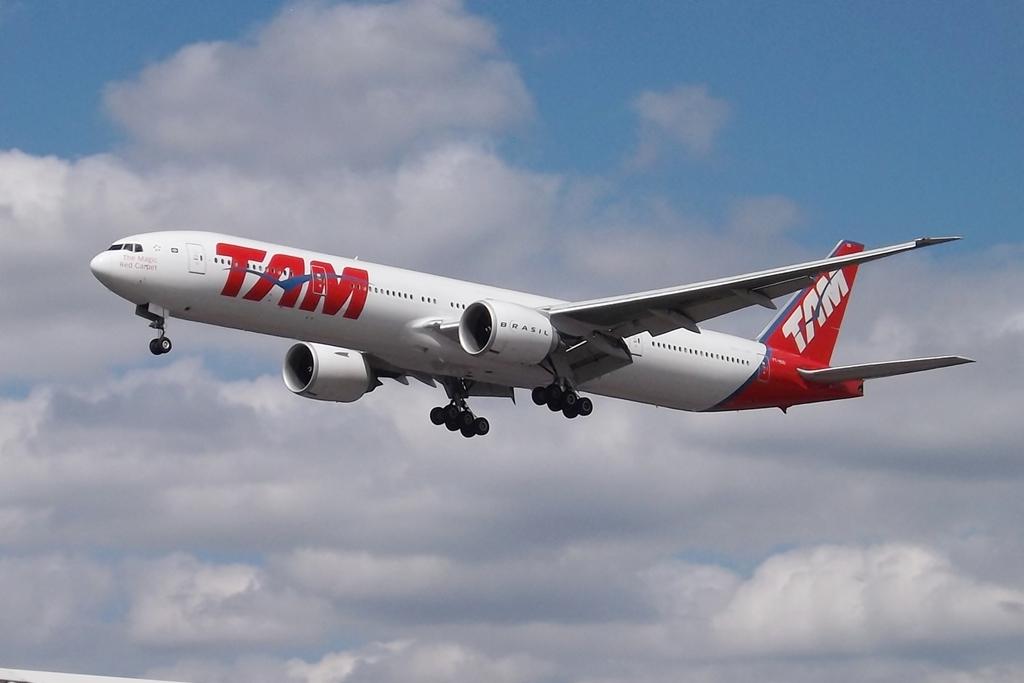What brand of jetliner is flying overhead?
Offer a very short reply. Tam. 